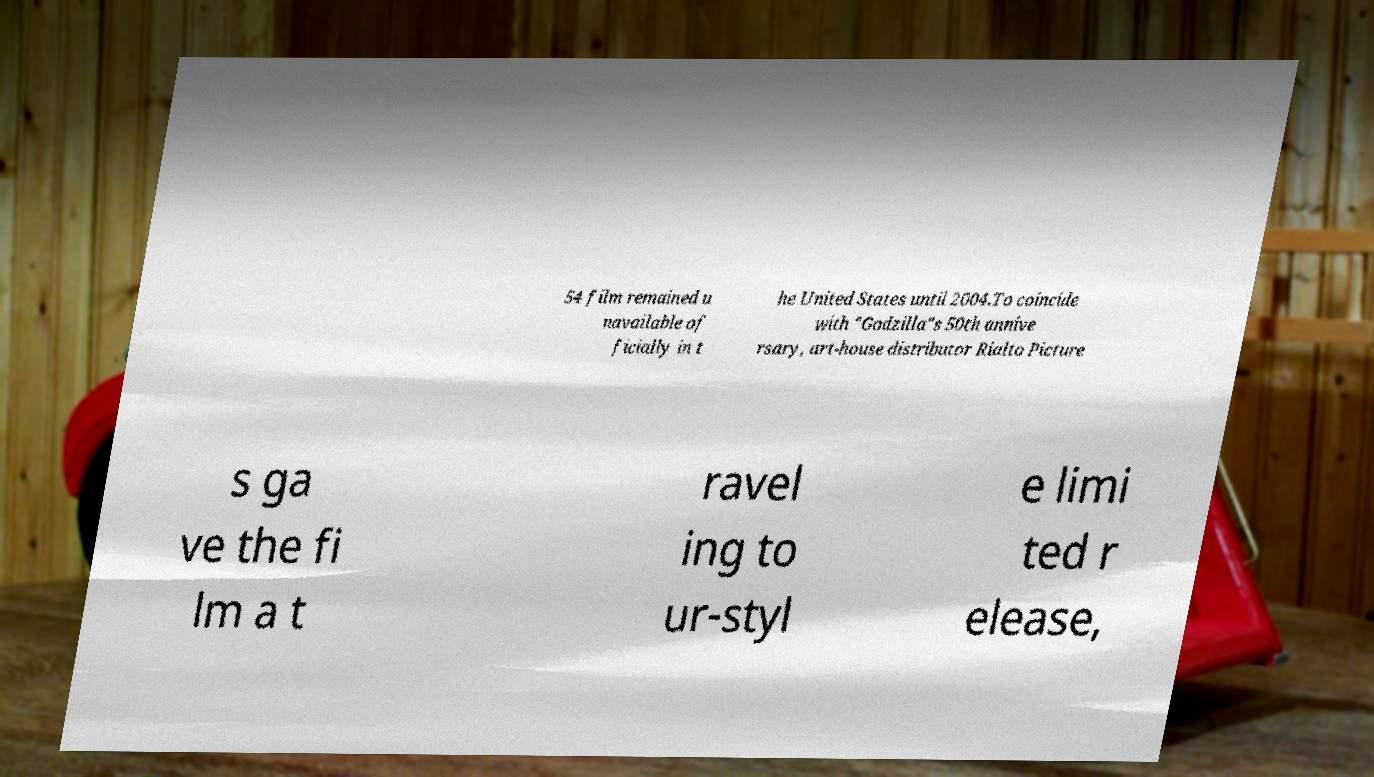Can you accurately transcribe the text from the provided image for me? 54 film remained u navailable of ficially in t he United States until 2004.To coincide with "Godzilla"s 50th annive rsary, art-house distributor Rialto Picture s ga ve the fi lm a t ravel ing to ur-styl e limi ted r elease, 